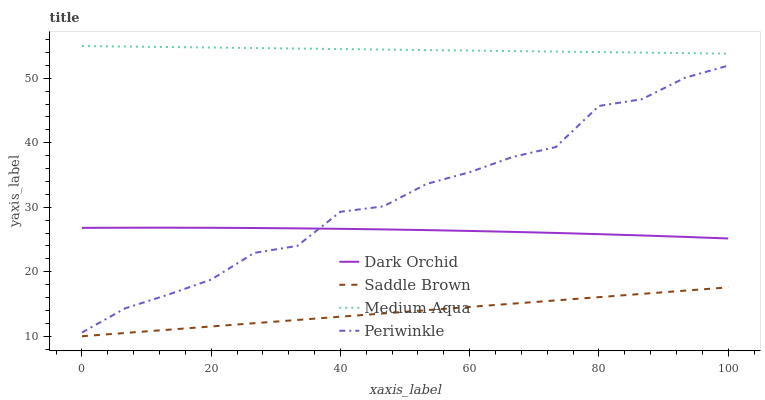Does Saddle Brown have the minimum area under the curve?
Answer yes or no. Yes. Does Medium Aqua have the maximum area under the curve?
Answer yes or no. Yes. Does Medium Aqua have the minimum area under the curve?
Answer yes or no. No. Does Saddle Brown have the maximum area under the curve?
Answer yes or no. No. Is Medium Aqua the smoothest?
Answer yes or no. Yes. Is Periwinkle the roughest?
Answer yes or no. Yes. Is Saddle Brown the smoothest?
Answer yes or no. No. Is Saddle Brown the roughest?
Answer yes or no. No. Does Saddle Brown have the lowest value?
Answer yes or no. Yes. Does Medium Aqua have the lowest value?
Answer yes or no. No. Does Medium Aqua have the highest value?
Answer yes or no. Yes. Does Saddle Brown have the highest value?
Answer yes or no. No. Is Saddle Brown less than Medium Aqua?
Answer yes or no. Yes. Is Medium Aqua greater than Periwinkle?
Answer yes or no. Yes. Does Periwinkle intersect Dark Orchid?
Answer yes or no. Yes. Is Periwinkle less than Dark Orchid?
Answer yes or no. No. Is Periwinkle greater than Dark Orchid?
Answer yes or no. No. Does Saddle Brown intersect Medium Aqua?
Answer yes or no. No. 